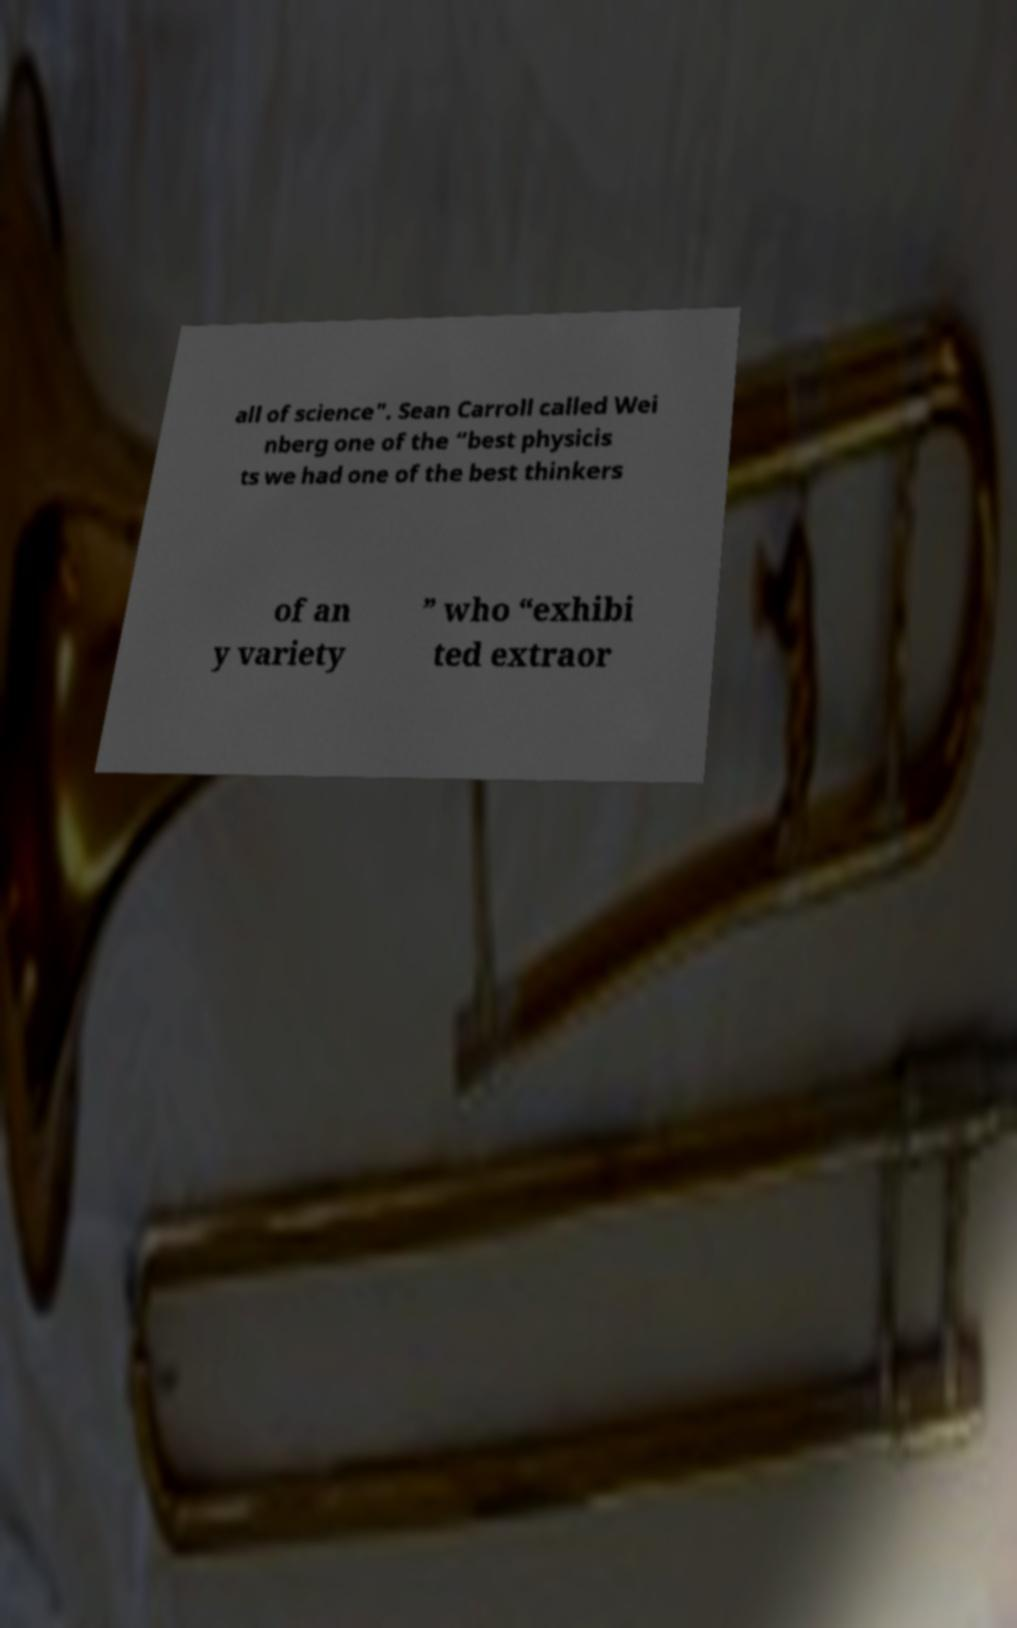I need the written content from this picture converted into text. Can you do that? all of science". Sean Carroll called Wei nberg one of the “best physicis ts we had one of the best thinkers of an y variety ” who “exhibi ted extraor 